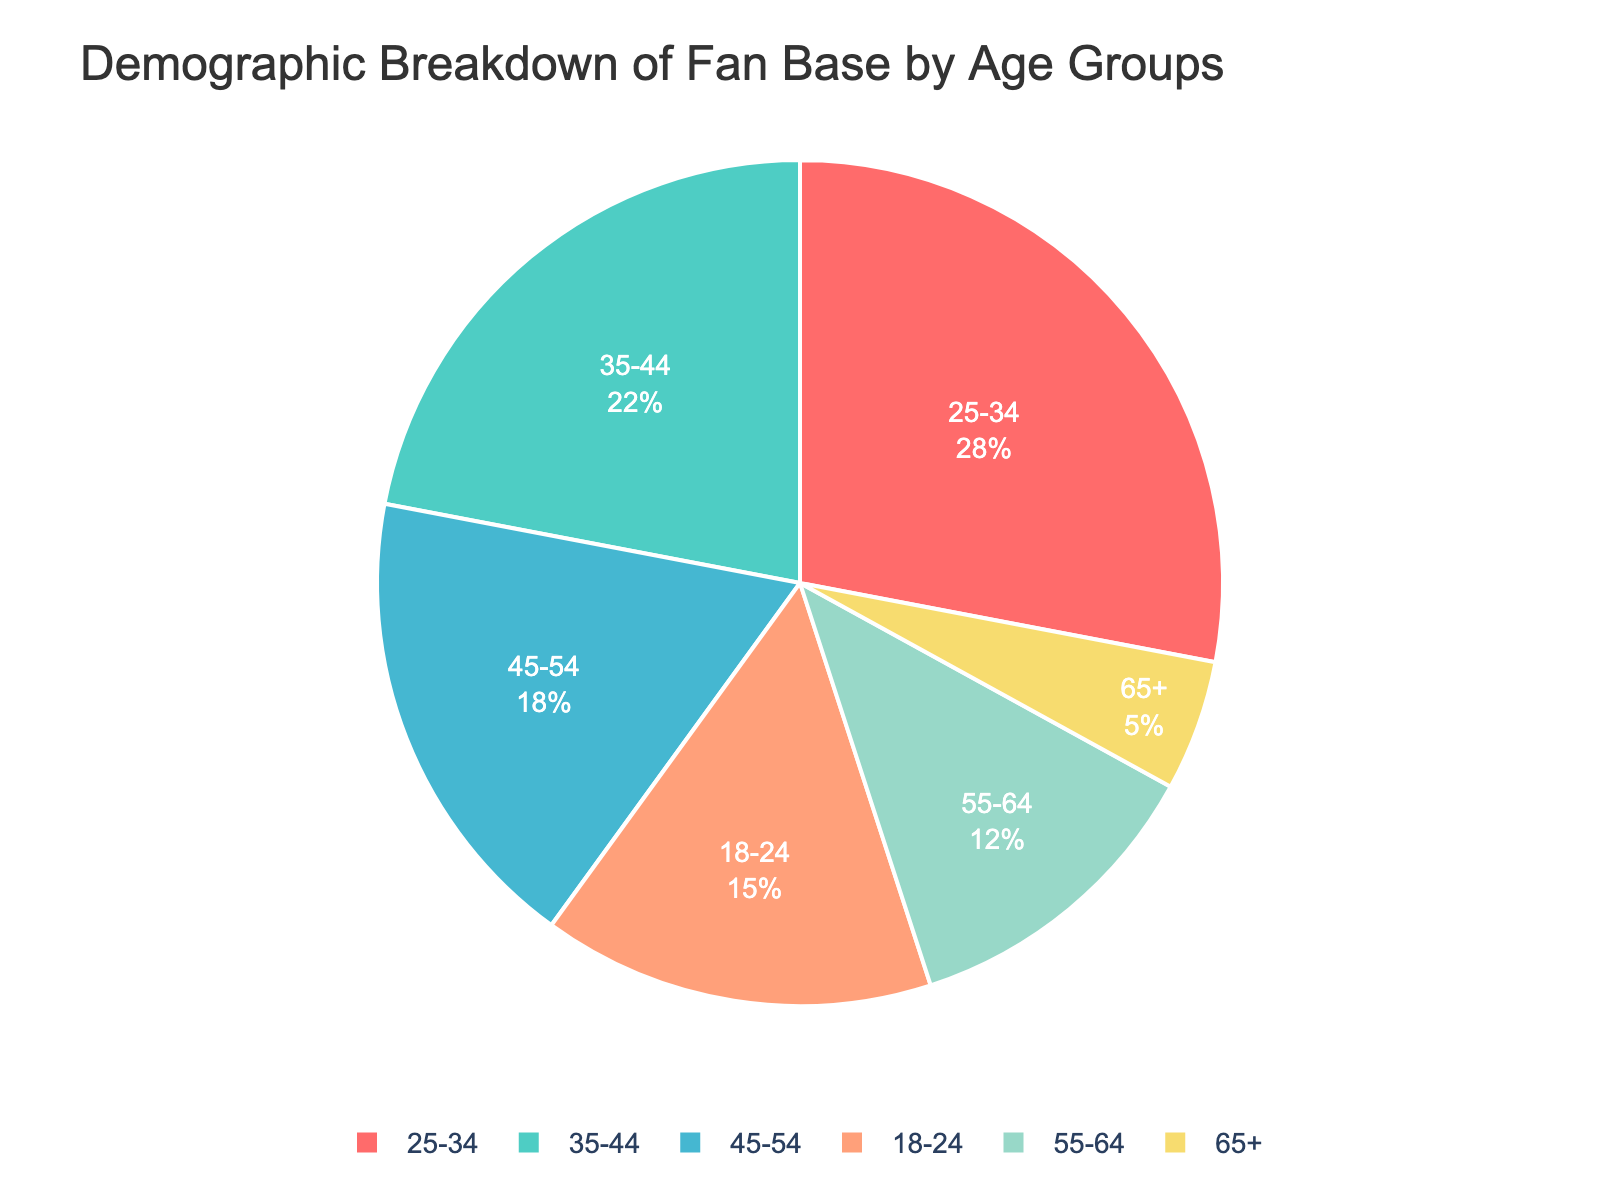Which age group has the highest percentage of fans? The figure shows a pie chart with a segment representing 28% for the 25-34 age group, which is the largest segment.
Answer: 25-34 What is the total percentage of fans aged 35-54? Add the percentages of the 35-44 and 45-54 age groups: 22% (35-44) + 18% (45-54) = 40%.
Answer: 40% Which age group has the smallest percentage of fans? The pie chart shows that the 65+ age group has the smallest segment with a 5% share.
Answer: 65+ How much larger is the percentage of fans aged 25-34 compared to the 55-64 age group? Subtract the percentage of the 55-64 age group from that of the 25-34 age group: 28% (25-34) - 12% (55-64) = 16%.
Answer: 16% What are the colors used in the pie chart for the 18-24 and 55-64 age groups? The segment for the 18-24 age group is red, and the 55-64 age group is shown in light green.
Answer: Red (18-24), Light green (55-64) How do the combined percentages of fans aged 18-24 and 65+ compare to those aged 45-54? Add the percentages of the 18-24 and 65+ age groups: 15% (18-24) + 5% (65+) = 20%. Compare it to the 45-54 age group which is 18%.
Answer: 20% vs. 18% What is the difference between the largest and smallest fan base percentages? Subtract the smallest percentage from the largest: 28% (25-34) - 5% (65+) = 23%.
Answer: 23% Which age groups have more than 20% of the fan base? The figure shows that 25-34 with 28% and 35-44 with 22% are both greater than 20%.
Answer: 25-34, 35-44 What is the median percentage of fans across all age groups? List the percentages: 5%, 12%, 15%, 18%, 22%, 28%, then find the median: (15% + 18%) / 2 = 16.5%.
Answer: 16.5% What percentage of fans does the 25-34 age group hold in the visualization? The pie chart specifically shows that the 25-34 age group makes up 28% of the fan base.
Answer: 28% 